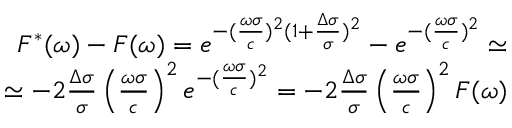Convert formula to latex. <formula><loc_0><loc_0><loc_500><loc_500>\begin{array} { r l r } & { F ^ { * } ( \omega ) - F ( \omega ) = e ^ { - ( \frac { \omega \sigma } { c } ) ^ { 2 } ( 1 + \frac { \Delta \sigma } { \sigma } ) ^ { 2 } } - e ^ { - ( \frac { \omega \sigma } { c } ) ^ { 2 } } \simeq } \\ & { \simeq - 2 \frac { \Delta \sigma } { \sigma } \left ( \frac { \omega \sigma } { c } \right ) ^ { 2 } e ^ { - ( \frac { \omega \sigma } { c } ) ^ { 2 } } = - 2 \frac { \Delta \sigma } { \sigma } \left ( \frac { \omega \sigma } { c } \right ) ^ { 2 } F ( \omega ) } \end{array}</formula> 